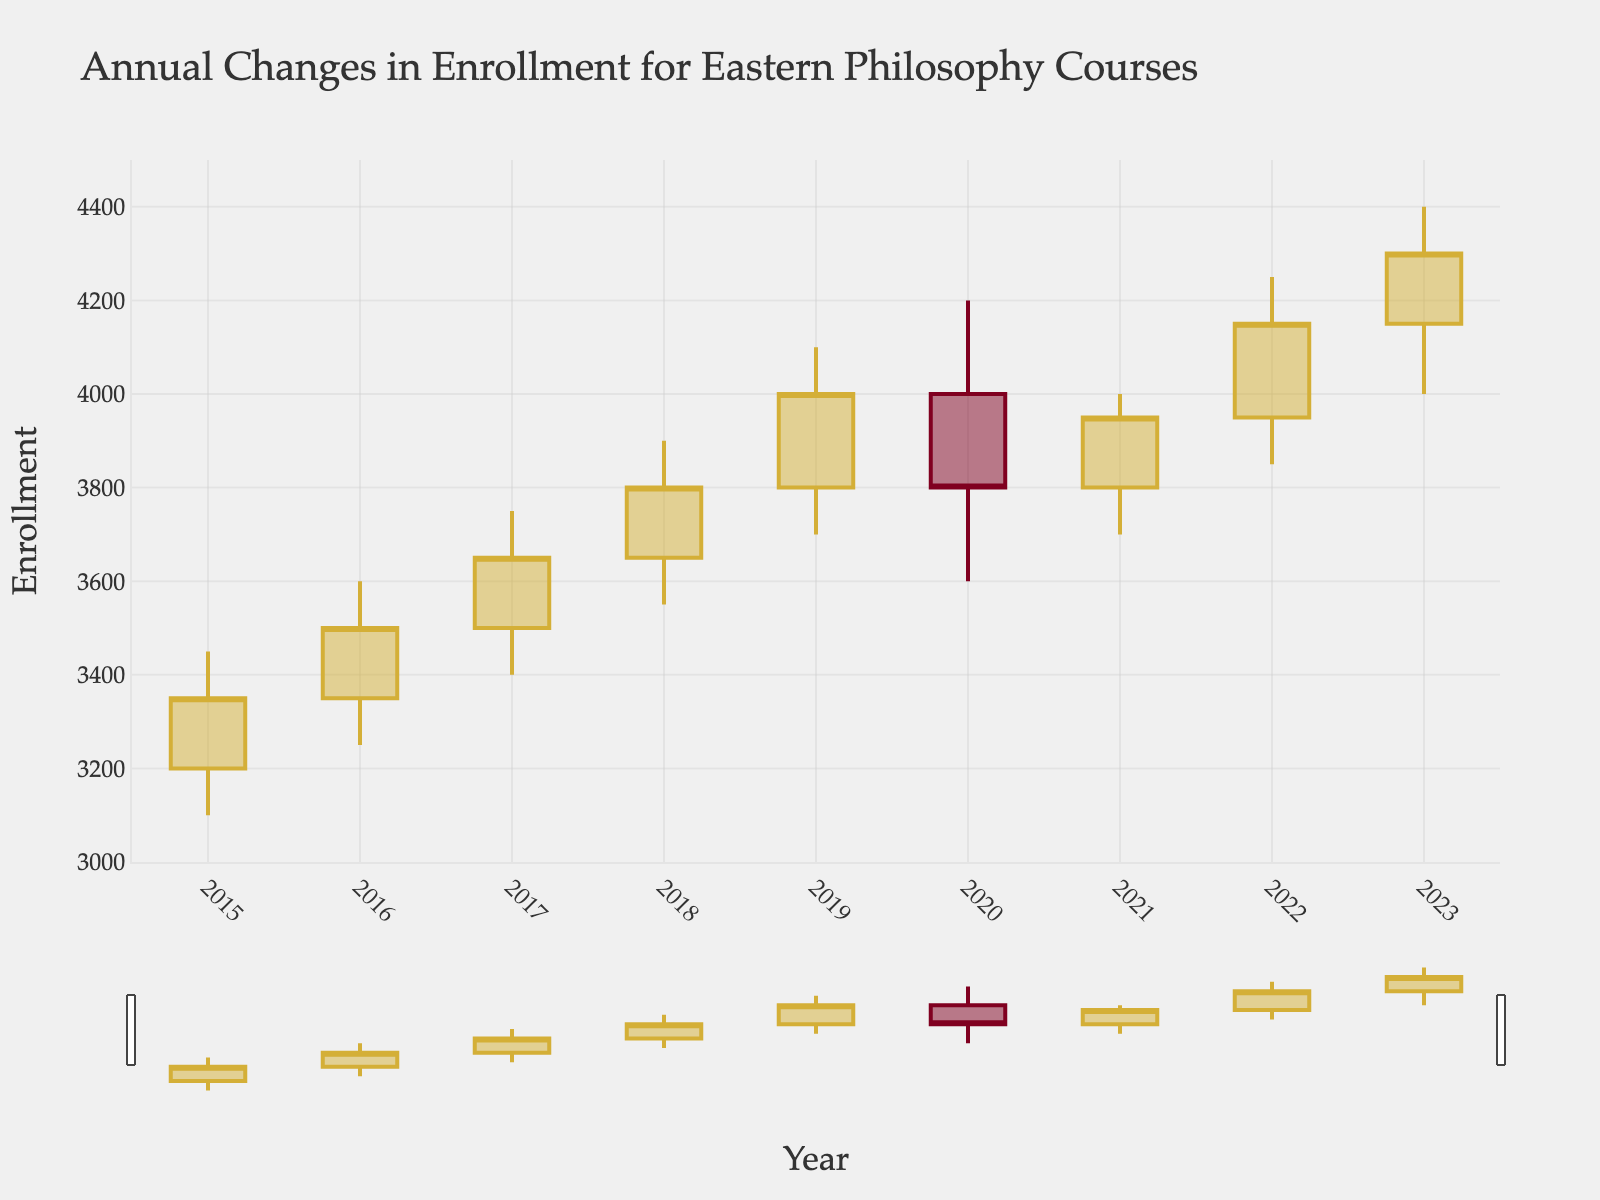What is the title of the figure? The title is displayed at the top of the figure. It provides a quick summary of what the chart is illustrating.
Answer: Annual Changes in Enrollment for Eastern Philosophy Courses How many years of data are shown in the figure? Count the number of x-axis labels representing different years.
Answer: 9 What was the highest enrollment for Eastern philosophy courses over the years? The highest value in the 'High' column gives the peak enrollment. According to the chart, the peak is around 4100 in 2019.
Answer: 4250 Which year had the lowest closing enrollment, and what was the value? The 'Close' values can be compared to determine the lowest. In 2020, the closing enrollment dipped to its lowest.
Answer: 3800 in 2020 What is the range of enrollments plotted on the y-axis? The y-axis shows enrollment numbers, typically ranging from the lowest to highest values present in the figure.
Answer: 3000 to 4500 By how much did the closing enrollment change from 2020 to 2021? Subtract the closing enrollment in 2020 from that in 2021: 3950 - 3800
Answer: 150 In which year did the open, high, and low enrollment values increase compared to the previous year? Check the open, high, and low columns year by year to see which year all three values are higher than the previous year.
Answer: All values increased in 2022 compared to 2021 Which year saw the biggest difference between the high and low enrollment values? Calculate the difference between 'High' and 'Low' each year and find the largest value. The difference for 2023 is 400.
Answer: 2023 Is there any year where the closing enrollment was equal to the high enrollment value? Compare the 'Close' and 'High' columns for each year to find any match. No such match exists.
Answer: No Which trend is depicted by the candlestick chart between 2015 and 2023? Analyze the pattern of increases and decreases shown by the candlestick bars over the years. Generally, there is an upward trend.
Answer: Upward trend 